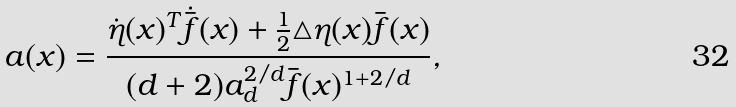<formula> <loc_0><loc_0><loc_500><loc_500>a ( x ) = \frac { \dot { \eta } ( x ) ^ { T } \dot { \bar { f } } ( x ) + \frac { 1 } { 2 } \triangle \eta ( x ) \bar { f } ( x ) } { ( d + 2 ) a _ { d } ^ { 2 / d } \bar { f } ( x ) ^ { 1 + 2 / d } } ,</formula> 